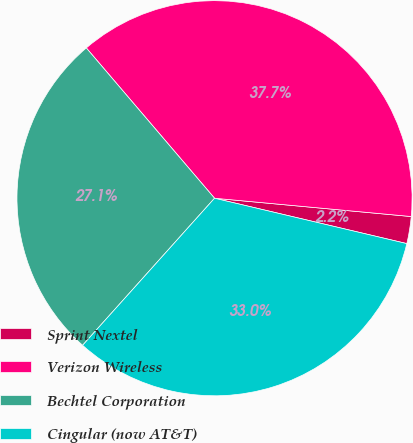<chart> <loc_0><loc_0><loc_500><loc_500><pie_chart><fcel>Sprint Nextel<fcel>Verizon Wireless<fcel>Bechtel Corporation<fcel>Cingular (now AT&T)<nl><fcel>2.21%<fcel>37.72%<fcel>27.12%<fcel>32.95%<nl></chart> 